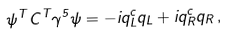Convert formula to latex. <formula><loc_0><loc_0><loc_500><loc_500>\psi ^ { T } C ^ { T } \gamma ^ { 5 } \psi = - i q _ { L } ^ { c } q _ { L } + i q _ { R } ^ { c } q _ { R } \, ,</formula> 